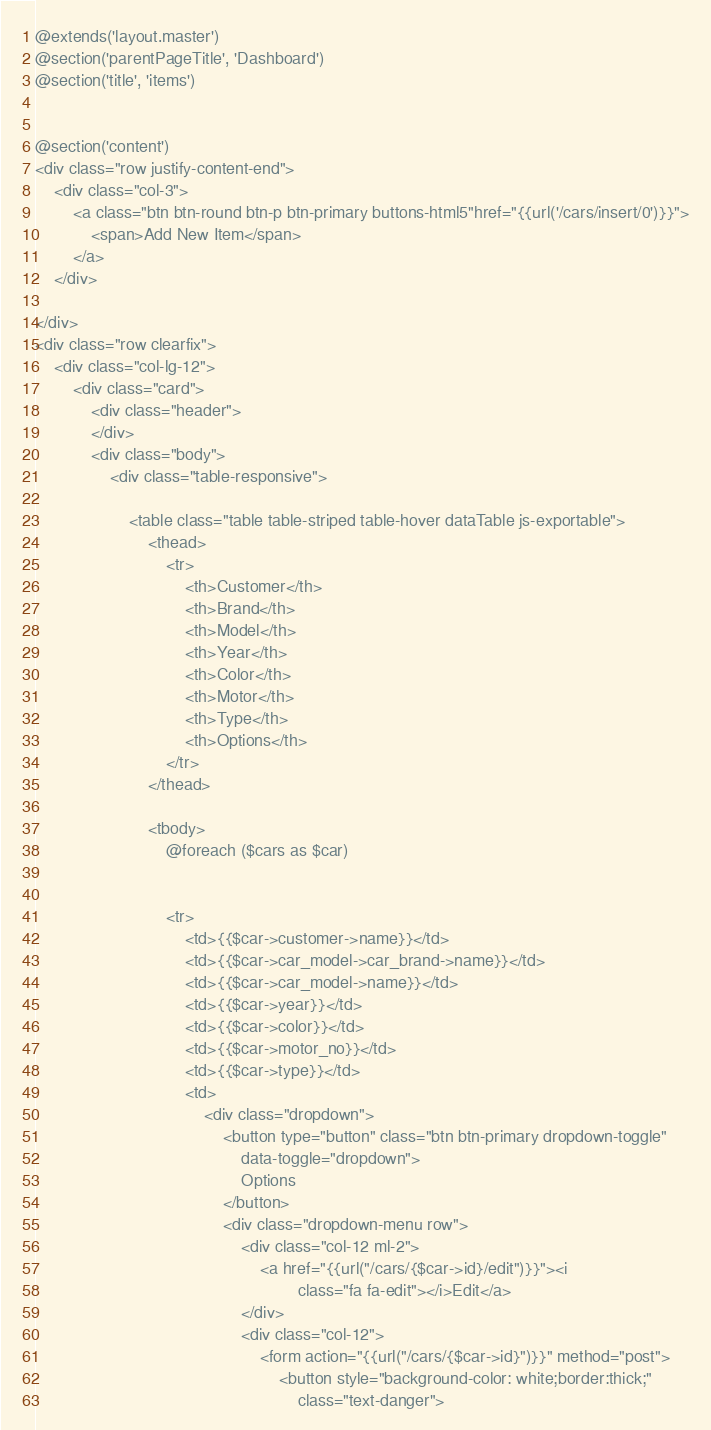Convert code to text. <code><loc_0><loc_0><loc_500><loc_500><_PHP_>@extends('layout.master')
@section('parentPageTitle', 'Dashboard')
@section('title', 'items')


@section('content')
<div class="row justify-content-end">
    <div class="col-3">
        <a class="btn btn-round btn-p btn-primary buttons-html5"href="{{url('/cars/insert/0')}}">
            <span>Add New Item</span>
        </a>
    </div>

</div>
<div class="row clearfix">
    <div class="col-lg-12">
        <div class="card">
            <div class="header">
            </div>
            <div class="body">
                <div class="table-responsive">

                    <table class="table table-striped table-hover dataTable js-exportable">
                        <thead>
                            <tr>
                                <th>Customer</th>
                                <th>Brand</th>
                                <th>Model</th>
                                <th>Year</th>
                                <th>Color</th>
                                <th>Motor</th>
                                <th>Type</th>
                                <th>Options</th>
                            </tr>
                        </thead>

                        <tbody>
                            @foreach ($cars as $car)


                            <tr>
                                <td>{{$car->customer->name}}</td>
                                <td>{{$car->car_model->car_brand->name}}</td>
                                <td>{{$car->car_model->name}}</td>
                                <td>{{$car->year}}</td>
                                <td>{{$car->color}}</td>
                                <td>{{$car->motor_no}}</td>
                                <td>{{$car->type}}</td>
                                <td>
                                    <div class="dropdown">
                                        <button type="button" class="btn btn-primary dropdown-toggle"
                                            data-toggle="dropdown">
                                            Options
                                        </button>
                                        <div class="dropdown-menu row">
                                            <div class="col-12 ml-2">
                                                <a href="{{url("/cars/{$car->id}/edit")}}"><i
                                                        class="fa fa-edit"></i>Edit</a>
                                            </div>
                                            <div class="col-12">
                                                <form action="{{url("/cars/{$car->id}")}}" method="post">
                                                    <button style="background-color: white;border:thick;"
                                                        class="text-danger"></code> 